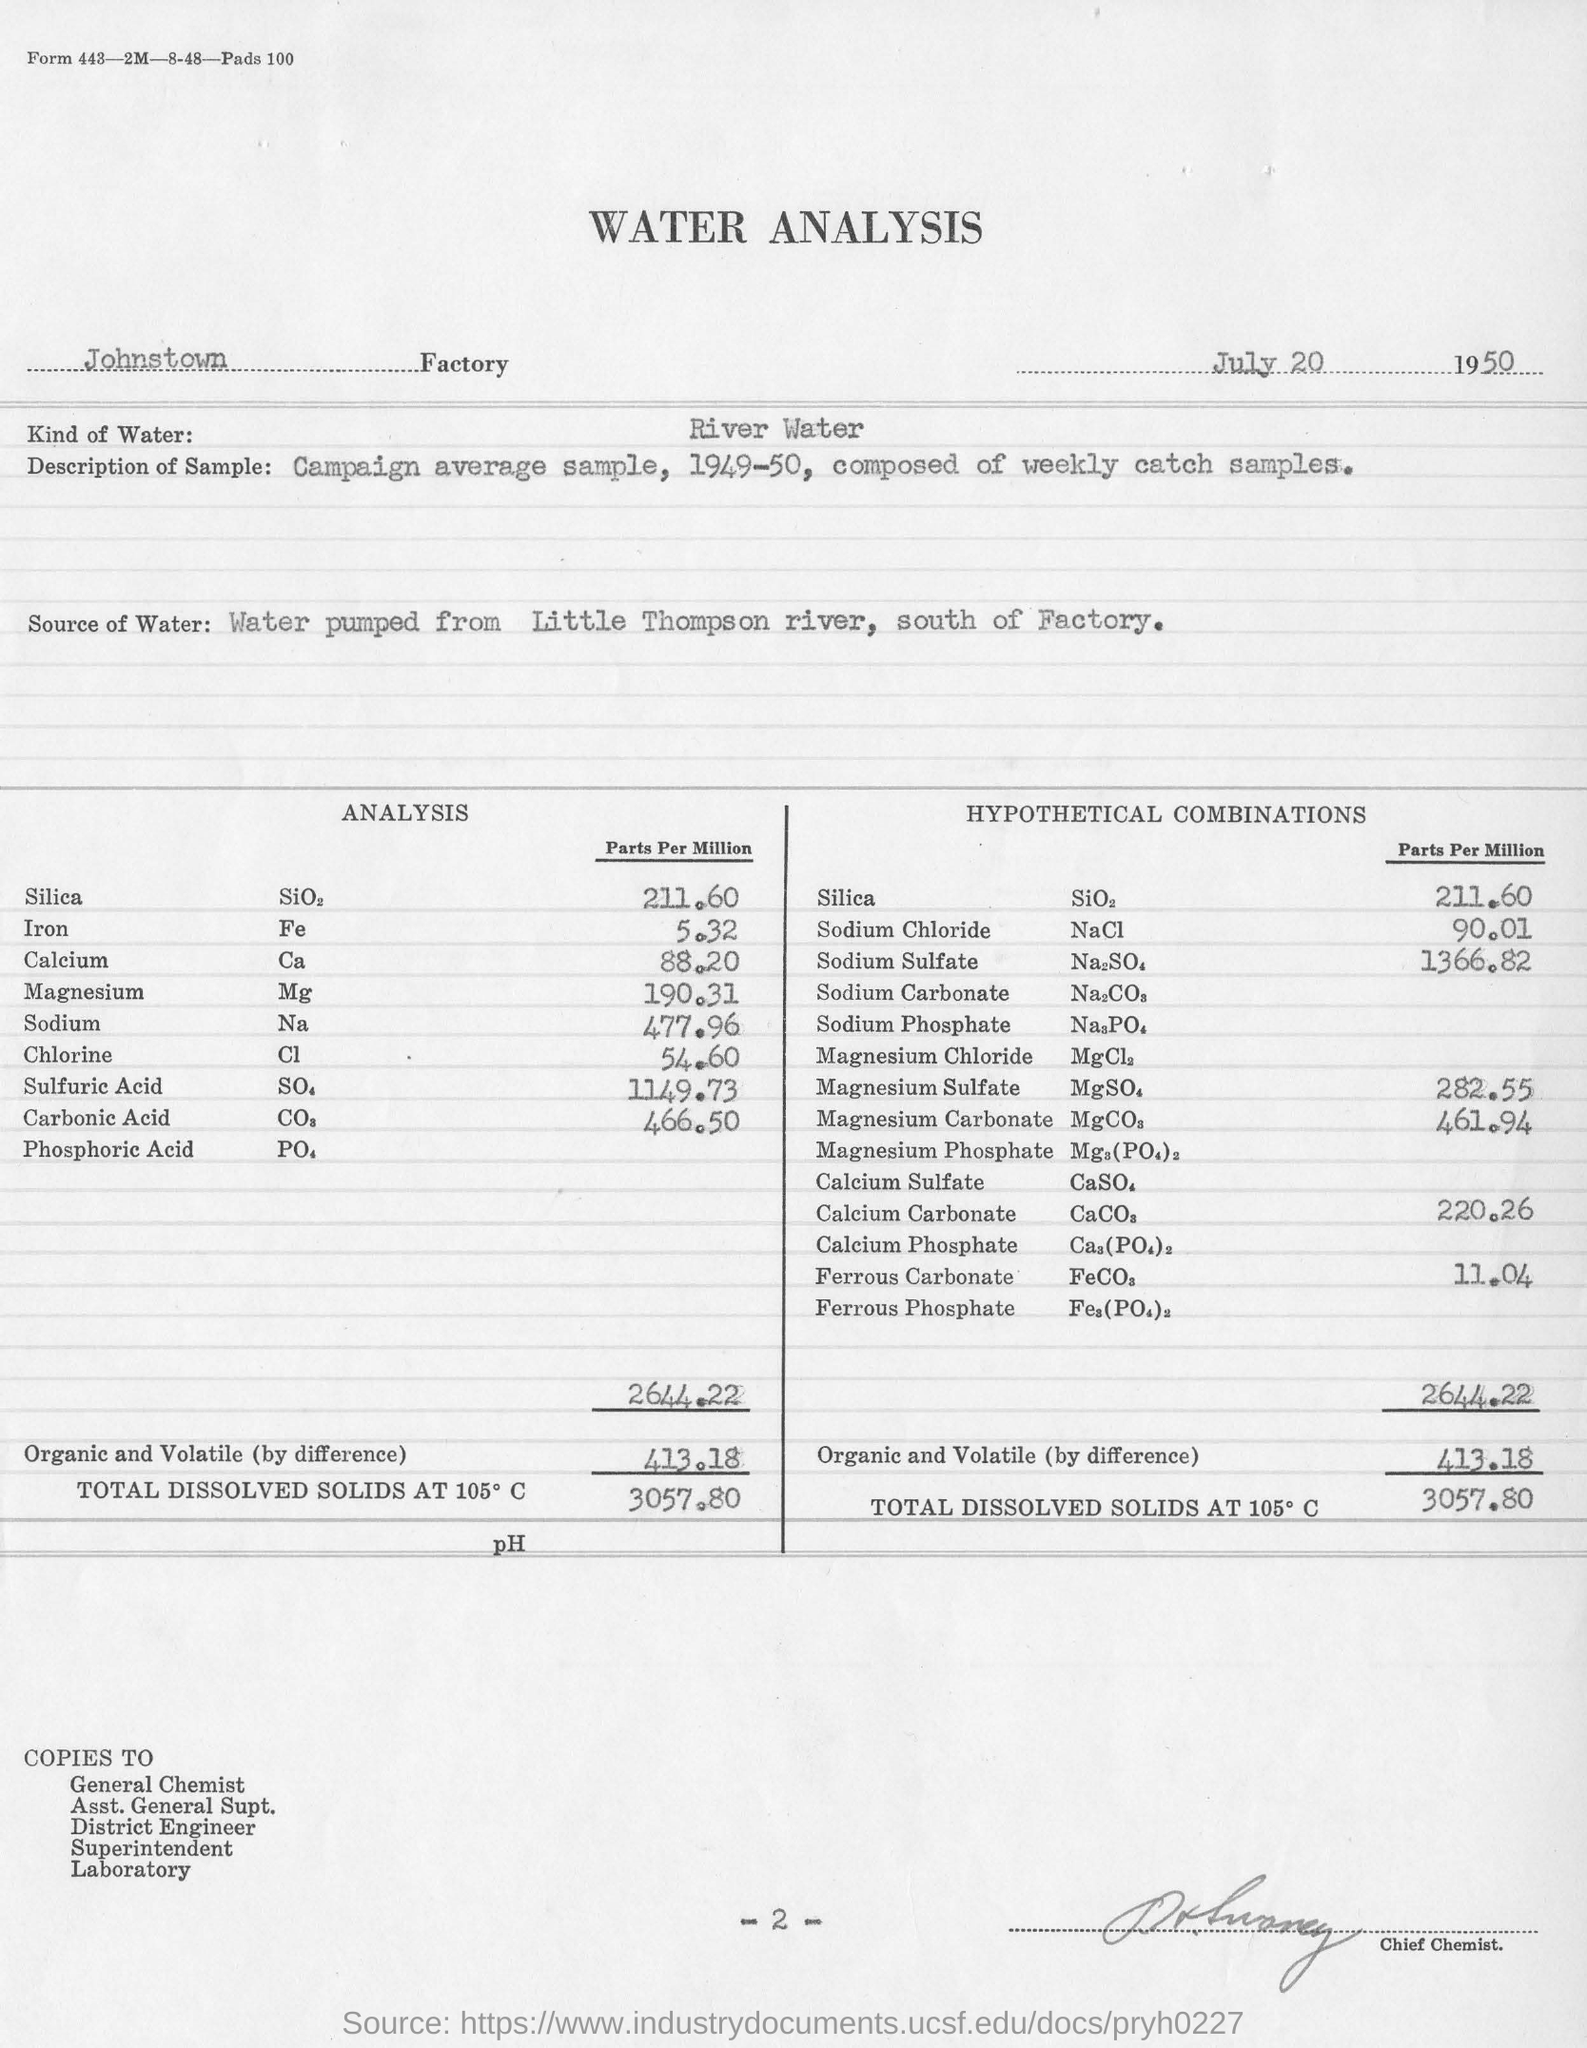When is the water analysis dated?
Your answer should be compact. July 20 1950. Which factory is mentioned?
Provide a succinct answer. Johnstown. What was the kind of water?
Offer a very short reply. River Water. Where was water pumped from?
Keep it short and to the point. Little Thompson river, south of Factory. What is the amount of total dissolved solids at 105 C according to analysis?
Your response must be concise. 3057.80. 